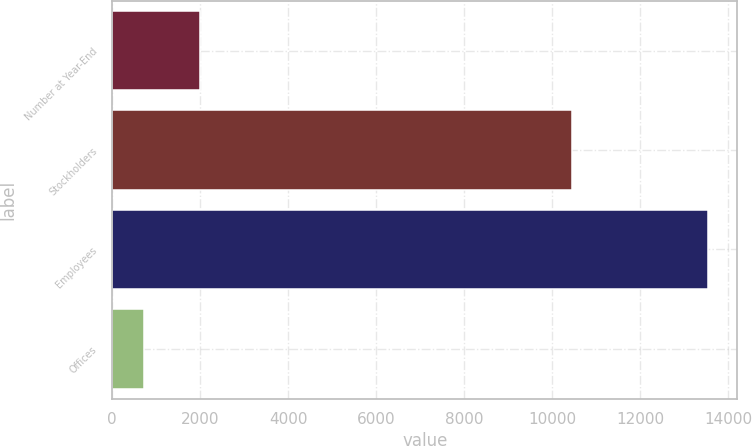Convert chart. <chart><loc_0><loc_0><loc_500><loc_500><bar_chart><fcel>Number at Year-End<fcel>Stockholders<fcel>Employees<fcel>Offices<nl><fcel>2005<fcel>10437<fcel>13525<fcel>724<nl></chart> 